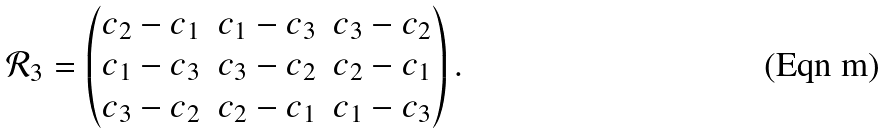Convert formula to latex. <formula><loc_0><loc_0><loc_500><loc_500>\mathcal { R } _ { 3 } = \begin{pmatrix} c _ { 2 } - c _ { 1 } & c _ { 1 } - c _ { 3 } & c _ { 3 } - c _ { 2 } \\ c _ { 1 } - c _ { 3 } & c _ { 3 } - c _ { 2 } & c _ { 2 } - c _ { 1 } \\ c _ { 3 } - c _ { 2 } & c _ { 2 } - c _ { 1 } & c _ { 1 } - c _ { 3 } \end{pmatrix} .</formula> 